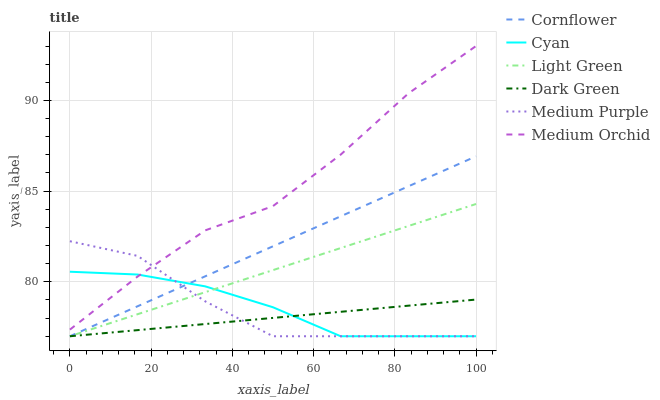Does Dark Green have the minimum area under the curve?
Answer yes or no. Yes. Does Medium Orchid have the maximum area under the curve?
Answer yes or no. Yes. Does Medium Purple have the minimum area under the curve?
Answer yes or no. No. Does Medium Purple have the maximum area under the curve?
Answer yes or no. No. Is Dark Green the smoothest?
Answer yes or no. Yes. Is Medium Orchid the roughest?
Answer yes or no. Yes. Is Medium Purple the smoothest?
Answer yes or no. No. Is Medium Purple the roughest?
Answer yes or no. No. Does Cornflower have the lowest value?
Answer yes or no. Yes. Does Medium Orchid have the lowest value?
Answer yes or no. No. Does Medium Orchid have the highest value?
Answer yes or no. Yes. Does Medium Purple have the highest value?
Answer yes or no. No. Is Cornflower less than Medium Orchid?
Answer yes or no. Yes. Is Medium Orchid greater than Cornflower?
Answer yes or no. Yes. Does Dark Green intersect Light Green?
Answer yes or no. Yes. Is Dark Green less than Light Green?
Answer yes or no. No. Is Dark Green greater than Light Green?
Answer yes or no. No. Does Cornflower intersect Medium Orchid?
Answer yes or no. No. 